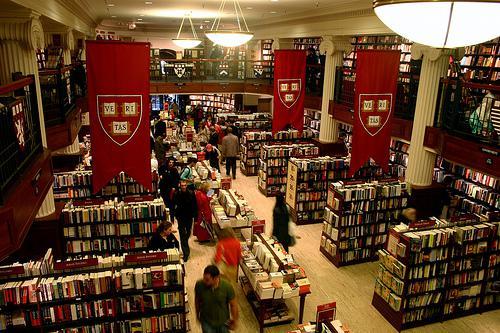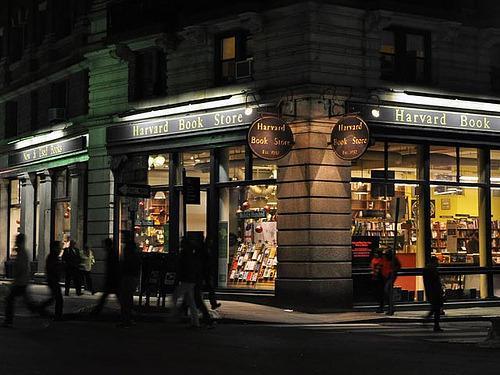The first image is the image on the left, the second image is the image on the right. For the images displayed, is the sentence "There are at least two people inside the store in the image on the right." factually correct? Answer yes or no. No. 